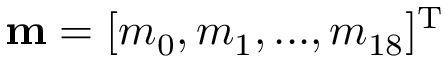Convert formula to latex. <formula><loc_0><loc_0><loc_500><loc_500>{ m } = { [ { m _ { 0 } } , { m _ { 1 } } , \dots , { m _ { 1 8 } } ] ^ { T } }</formula> 